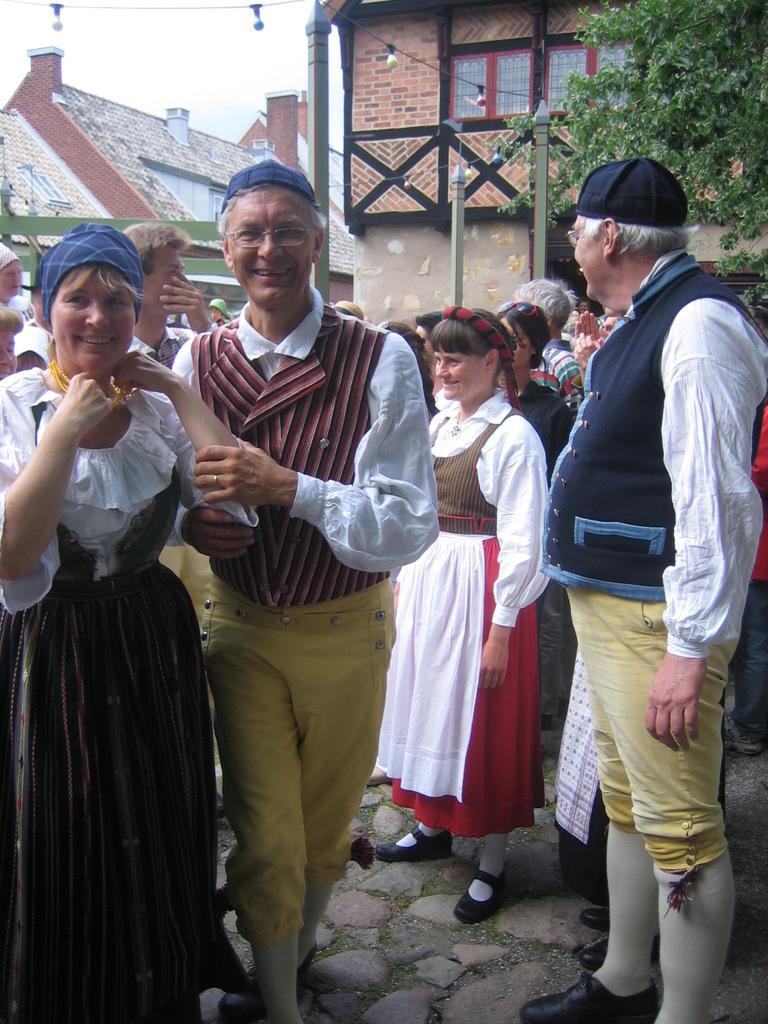What can be observed about the people in the image? There are people standing in the image, and they have smiles on their faces. What is visible in the background of the image? Trees and buildings can be seen in the background of the image. What type of lighting is present in the image? Lamps are hanging at the top of the image. Can you tell me how many pickles are being kicked by the people in the image? There are no pickles or kicking activities present in the image. 